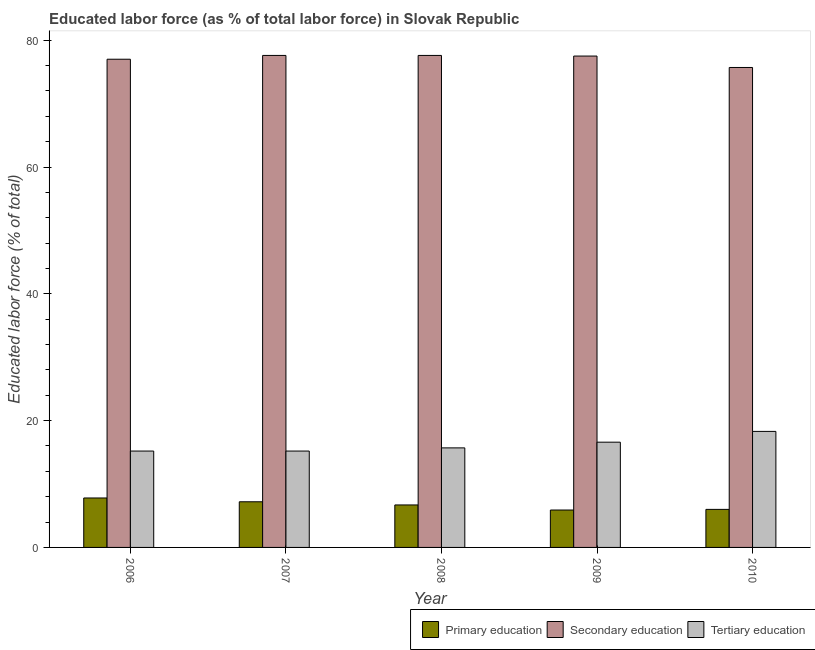How many groups of bars are there?
Your response must be concise. 5. Are the number of bars on each tick of the X-axis equal?
Keep it short and to the point. Yes. How many bars are there on the 1st tick from the left?
Your response must be concise. 3. What is the label of the 2nd group of bars from the left?
Make the answer very short. 2007. What is the percentage of labor force who received secondary education in 2008?
Ensure brevity in your answer.  77.6. Across all years, what is the maximum percentage of labor force who received secondary education?
Provide a short and direct response. 77.6. Across all years, what is the minimum percentage of labor force who received primary education?
Provide a succinct answer. 5.9. In which year was the percentage of labor force who received primary education maximum?
Provide a succinct answer. 2006. What is the total percentage of labor force who received tertiary education in the graph?
Ensure brevity in your answer.  81. What is the difference between the percentage of labor force who received tertiary education in 2008 and that in 2009?
Ensure brevity in your answer.  -0.9. What is the difference between the percentage of labor force who received tertiary education in 2007 and the percentage of labor force who received secondary education in 2008?
Keep it short and to the point. -0.5. What is the average percentage of labor force who received primary education per year?
Offer a very short reply. 6.72. In the year 2007, what is the difference between the percentage of labor force who received tertiary education and percentage of labor force who received primary education?
Your answer should be compact. 0. In how many years, is the percentage of labor force who received secondary education greater than 28 %?
Provide a succinct answer. 5. What is the ratio of the percentage of labor force who received secondary education in 2006 to that in 2007?
Give a very brief answer. 0.99. What is the difference between the highest and the second highest percentage of labor force who received primary education?
Make the answer very short. 0.6. What is the difference between the highest and the lowest percentage of labor force who received primary education?
Keep it short and to the point. 1.9. What does the 3rd bar from the left in 2009 represents?
Your response must be concise. Tertiary education. What does the 2nd bar from the right in 2007 represents?
Offer a terse response. Secondary education. Are all the bars in the graph horizontal?
Ensure brevity in your answer.  No. How many years are there in the graph?
Your response must be concise. 5. What is the difference between two consecutive major ticks on the Y-axis?
Give a very brief answer. 20. Does the graph contain grids?
Give a very brief answer. No. Where does the legend appear in the graph?
Offer a terse response. Bottom right. How many legend labels are there?
Keep it short and to the point. 3. How are the legend labels stacked?
Offer a very short reply. Horizontal. What is the title of the graph?
Your answer should be very brief. Educated labor force (as % of total labor force) in Slovak Republic. Does "Food" appear as one of the legend labels in the graph?
Offer a very short reply. No. What is the label or title of the Y-axis?
Your response must be concise. Educated labor force (% of total). What is the Educated labor force (% of total) of Primary education in 2006?
Make the answer very short. 7.8. What is the Educated labor force (% of total) in Secondary education in 2006?
Ensure brevity in your answer.  77. What is the Educated labor force (% of total) of Tertiary education in 2006?
Offer a terse response. 15.2. What is the Educated labor force (% of total) of Primary education in 2007?
Offer a very short reply. 7.2. What is the Educated labor force (% of total) of Secondary education in 2007?
Your answer should be compact. 77.6. What is the Educated labor force (% of total) of Tertiary education in 2007?
Keep it short and to the point. 15.2. What is the Educated labor force (% of total) of Primary education in 2008?
Provide a succinct answer. 6.7. What is the Educated labor force (% of total) of Secondary education in 2008?
Provide a succinct answer. 77.6. What is the Educated labor force (% of total) of Tertiary education in 2008?
Keep it short and to the point. 15.7. What is the Educated labor force (% of total) in Primary education in 2009?
Provide a succinct answer. 5.9. What is the Educated labor force (% of total) in Secondary education in 2009?
Your response must be concise. 77.5. What is the Educated labor force (% of total) of Tertiary education in 2009?
Provide a short and direct response. 16.6. What is the Educated labor force (% of total) in Secondary education in 2010?
Your response must be concise. 75.7. What is the Educated labor force (% of total) in Tertiary education in 2010?
Give a very brief answer. 18.3. Across all years, what is the maximum Educated labor force (% of total) of Primary education?
Your answer should be compact. 7.8. Across all years, what is the maximum Educated labor force (% of total) in Secondary education?
Provide a short and direct response. 77.6. Across all years, what is the maximum Educated labor force (% of total) of Tertiary education?
Ensure brevity in your answer.  18.3. Across all years, what is the minimum Educated labor force (% of total) in Primary education?
Make the answer very short. 5.9. Across all years, what is the minimum Educated labor force (% of total) of Secondary education?
Ensure brevity in your answer.  75.7. Across all years, what is the minimum Educated labor force (% of total) in Tertiary education?
Provide a short and direct response. 15.2. What is the total Educated labor force (% of total) of Primary education in the graph?
Make the answer very short. 33.6. What is the total Educated labor force (% of total) in Secondary education in the graph?
Keep it short and to the point. 385.4. What is the total Educated labor force (% of total) of Tertiary education in the graph?
Ensure brevity in your answer.  81. What is the difference between the Educated labor force (% of total) in Tertiary education in 2006 and that in 2007?
Offer a very short reply. 0. What is the difference between the Educated labor force (% of total) of Secondary education in 2006 and that in 2010?
Provide a succinct answer. 1.3. What is the difference between the Educated labor force (% of total) of Tertiary education in 2006 and that in 2010?
Ensure brevity in your answer.  -3.1. What is the difference between the Educated labor force (% of total) in Primary education in 2007 and that in 2008?
Your response must be concise. 0.5. What is the difference between the Educated labor force (% of total) in Secondary education in 2007 and that in 2008?
Ensure brevity in your answer.  0. What is the difference between the Educated labor force (% of total) in Tertiary education in 2007 and that in 2008?
Your answer should be very brief. -0.5. What is the difference between the Educated labor force (% of total) of Primary education in 2007 and that in 2009?
Keep it short and to the point. 1.3. What is the difference between the Educated labor force (% of total) in Secondary education in 2007 and that in 2009?
Keep it short and to the point. 0.1. What is the difference between the Educated labor force (% of total) in Primary education in 2007 and that in 2010?
Your response must be concise. 1.2. What is the difference between the Educated labor force (% of total) of Secondary education in 2007 and that in 2010?
Give a very brief answer. 1.9. What is the difference between the Educated labor force (% of total) of Tertiary education in 2007 and that in 2010?
Offer a terse response. -3.1. What is the difference between the Educated labor force (% of total) in Secondary education in 2008 and that in 2009?
Provide a succinct answer. 0.1. What is the difference between the Educated labor force (% of total) in Tertiary education in 2008 and that in 2009?
Keep it short and to the point. -0.9. What is the difference between the Educated labor force (% of total) of Primary education in 2008 and that in 2010?
Ensure brevity in your answer.  0.7. What is the difference between the Educated labor force (% of total) in Secondary education in 2008 and that in 2010?
Give a very brief answer. 1.9. What is the difference between the Educated labor force (% of total) of Primary education in 2006 and the Educated labor force (% of total) of Secondary education in 2007?
Offer a very short reply. -69.8. What is the difference between the Educated labor force (% of total) of Primary education in 2006 and the Educated labor force (% of total) of Tertiary education in 2007?
Provide a succinct answer. -7.4. What is the difference between the Educated labor force (% of total) of Secondary education in 2006 and the Educated labor force (% of total) of Tertiary education in 2007?
Make the answer very short. 61.8. What is the difference between the Educated labor force (% of total) in Primary education in 2006 and the Educated labor force (% of total) in Secondary education in 2008?
Offer a very short reply. -69.8. What is the difference between the Educated labor force (% of total) in Secondary education in 2006 and the Educated labor force (% of total) in Tertiary education in 2008?
Ensure brevity in your answer.  61.3. What is the difference between the Educated labor force (% of total) in Primary education in 2006 and the Educated labor force (% of total) in Secondary education in 2009?
Provide a succinct answer. -69.7. What is the difference between the Educated labor force (% of total) of Primary education in 2006 and the Educated labor force (% of total) of Tertiary education in 2009?
Keep it short and to the point. -8.8. What is the difference between the Educated labor force (% of total) in Secondary education in 2006 and the Educated labor force (% of total) in Tertiary education in 2009?
Offer a terse response. 60.4. What is the difference between the Educated labor force (% of total) in Primary education in 2006 and the Educated labor force (% of total) in Secondary education in 2010?
Provide a short and direct response. -67.9. What is the difference between the Educated labor force (% of total) of Primary education in 2006 and the Educated labor force (% of total) of Tertiary education in 2010?
Provide a succinct answer. -10.5. What is the difference between the Educated labor force (% of total) in Secondary education in 2006 and the Educated labor force (% of total) in Tertiary education in 2010?
Your response must be concise. 58.7. What is the difference between the Educated labor force (% of total) in Primary education in 2007 and the Educated labor force (% of total) in Secondary education in 2008?
Offer a terse response. -70.4. What is the difference between the Educated labor force (% of total) in Secondary education in 2007 and the Educated labor force (% of total) in Tertiary education in 2008?
Offer a terse response. 61.9. What is the difference between the Educated labor force (% of total) in Primary education in 2007 and the Educated labor force (% of total) in Secondary education in 2009?
Provide a short and direct response. -70.3. What is the difference between the Educated labor force (% of total) in Primary education in 2007 and the Educated labor force (% of total) in Secondary education in 2010?
Provide a short and direct response. -68.5. What is the difference between the Educated labor force (% of total) of Primary education in 2007 and the Educated labor force (% of total) of Tertiary education in 2010?
Provide a short and direct response. -11.1. What is the difference between the Educated labor force (% of total) of Secondary education in 2007 and the Educated labor force (% of total) of Tertiary education in 2010?
Ensure brevity in your answer.  59.3. What is the difference between the Educated labor force (% of total) in Primary education in 2008 and the Educated labor force (% of total) in Secondary education in 2009?
Provide a succinct answer. -70.8. What is the difference between the Educated labor force (% of total) of Primary education in 2008 and the Educated labor force (% of total) of Tertiary education in 2009?
Provide a succinct answer. -9.9. What is the difference between the Educated labor force (% of total) in Secondary education in 2008 and the Educated labor force (% of total) in Tertiary education in 2009?
Your answer should be compact. 61. What is the difference between the Educated labor force (% of total) in Primary education in 2008 and the Educated labor force (% of total) in Secondary education in 2010?
Provide a succinct answer. -69. What is the difference between the Educated labor force (% of total) of Primary education in 2008 and the Educated labor force (% of total) of Tertiary education in 2010?
Offer a terse response. -11.6. What is the difference between the Educated labor force (% of total) in Secondary education in 2008 and the Educated labor force (% of total) in Tertiary education in 2010?
Keep it short and to the point. 59.3. What is the difference between the Educated labor force (% of total) of Primary education in 2009 and the Educated labor force (% of total) of Secondary education in 2010?
Offer a very short reply. -69.8. What is the difference between the Educated labor force (% of total) of Primary education in 2009 and the Educated labor force (% of total) of Tertiary education in 2010?
Provide a succinct answer. -12.4. What is the difference between the Educated labor force (% of total) of Secondary education in 2009 and the Educated labor force (% of total) of Tertiary education in 2010?
Your answer should be very brief. 59.2. What is the average Educated labor force (% of total) of Primary education per year?
Your answer should be very brief. 6.72. What is the average Educated labor force (% of total) in Secondary education per year?
Provide a succinct answer. 77.08. In the year 2006, what is the difference between the Educated labor force (% of total) of Primary education and Educated labor force (% of total) of Secondary education?
Your response must be concise. -69.2. In the year 2006, what is the difference between the Educated labor force (% of total) in Primary education and Educated labor force (% of total) in Tertiary education?
Your answer should be very brief. -7.4. In the year 2006, what is the difference between the Educated labor force (% of total) in Secondary education and Educated labor force (% of total) in Tertiary education?
Provide a succinct answer. 61.8. In the year 2007, what is the difference between the Educated labor force (% of total) of Primary education and Educated labor force (% of total) of Secondary education?
Your answer should be compact. -70.4. In the year 2007, what is the difference between the Educated labor force (% of total) in Secondary education and Educated labor force (% of total) in Tertiary education?
Your answer should be compact. 62.4. In the year 2008, what is the difference between the Educated labor force (% of total) of Primary education and Educated labor force (% of total) of Secondary education?
Make the answer very short. -70.9. In the year 2008, what is the difference between the Educated labor force (% of total) of Primary education and Educated labor force (% of total) of Tertiary education?
Your response must be concise. -9. In the year 2008, what is the difference between the Educated labor force (% of total) of Secondary education and Educated labor force (% of total) of Tertiary education?
Your answer should be compact. 61.9. In the year 2009, what is the difference between the Educated labor force (% of total) of Primary education and Educated labor force (% of total) of Secondary education?
Offer a terse response. -71.6. In the year 2009, what is the difference between the Educated labor force (% of total) in Secondary education and Educated labor force (% of total) in Tertiary education?
Keep it short and to the point. 60.9. In the year 2010, what is the difference between the Educated labor force (% of total) of Primary education and Educated labor force (% of total) of Secondary education?
Offer a very short reply. -69.7. In the year 2010, what is the difference between the Educated labor force (% of total) in Secondary education and Educated labor force (% of total) in Tertiary education?
Offer a very short reply. 57.4. What is the ratio of the Educated labor force (% of total) of Primary education in 2006 to that in 2007?
Your answer should be very brief. 1.08. What is the ratio of the Educated labor force (% of total) of Primary education in 2006 to that in 2008?
Offer a terse response. 1.16. What is the ratio of the Educated labor force (% of total) in Tertiary education in 2006 to that in 2008?
Ensure brevity in your answer.  0.97. What is the ratio of the Educated labor force (% of total) of Primary education in 2006 to that in 2009?
Provide a short and direct response. 1.32. What is the ratio of the Educated labor force (% of total) in Tertiary education in 2006 to that in 2009?
Provide a succinct answer. 0.92. What is the ratio of the Educated labor force (% of total) in Primary education in 2006 to that in 2010?
Offer a terse response. 1.3. What is the ratio of the Educated labor force (% of total) of Secondary education in 2006 to that in 2010?
Your response must be concise. 1.02. What is the ratio of the Educated labor force (% of total) of Tertiary education in 2006 to that in 2010?
Your answer should be compact. 0.83. What is the ratio of the Educated labor force (% of total) in Primary education in 2007 to that in 2008?
Offer a very short reply. 1.07. What is the ratio of the Educated labor force (% of total) in Tertiary education in 2007 to that in 2008?
Provide a short and direct response. 0.97. What is the ratio of the Educated labor force (% of total) of Primary education in 2007 to that in 2009?
Give a very brief answer. 1.22. What is the ratio of the Educated labor force (% of total) in Secondary education in 2007 to that in 2009?
Your answer should be compact. 1. What is the ratio of the Educated labor force (% of total) of Tertiary education in 2007 to that in 2009?
Give a very brief answer. 0.92. What is the ratio of the Educated labor force (% of total) in Secondary education in 2007 to that in 2010?
Keep it short and to the point. 1.03. What is the ratio of the Educated labor force (% of total) of Tertiary education in 2007 to that in 2010?
Offer a very short reply. 0.83. What is the ratio of the Educated labor force (% of total) of Primary education in 2008 to that in 2009?
Your answer should be very brief. 1.14. What is the ratio of the Educated labor force (% of total) in Secondary education in 2008 to that in 2009?
Give a very brief answer. 1. What is the ratio of the Educated labor force (% of total) of Tertiary education in 2008 to that in 2009?
Your answer should be very brief. 0.95. What is the ratio of the Educated labor force (% of total) in Primary education in 2008 to that in 2010?
Keep it short and to the point. 1.12. What is the ratio of the Educated labor force (% of total) of Secondary education in 2008 to that in 2010?
Offer a very short reply. 1.03. What is the ratio of the Educated labor force (% of total) in Tertiary education in 2008 to that in 2010?
Your response must be concise. 0.86. What is the ratio of the Educated labor force (% of total) of Primary education in 2009 to that in 2010?
Provide a short and direct response. 0.98. What is the ratio of the Educated labor force (% of total) in Secondary education in 2009 to that in 2010?
Your response must be concise. 1.02. What is the ratio of the Educated labor force (% of total) in Tertiary education in 2009 to that in 2010?
Make the answer very short. 0.91. What is the difference between the highest and the second highest Educated labor force (% of total) in Primary education?
Provide a succinct answer. 0.6. What is the difference between the highest and the second highest Educated labor force (% of total) of Tertiary education?
Ensure brevity in your answer.  1.7. What is the difference between the highest and the lowest Educated labor force (% of total) of Primary education?
Provide a succinct answer. 1.9. What is the difference between the highest and the lowest Educated labor force (% of total) in Tertiary education?
Offer a very short reply. 3.1. 